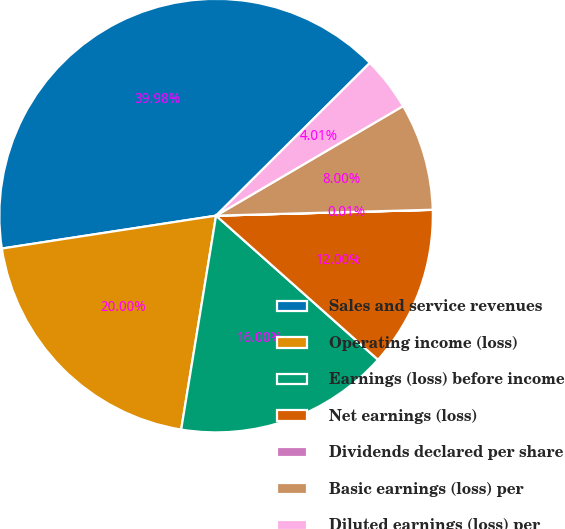<chart> <loc_0><loc_0><loc_500><loc_500><pie_chart><fcel>Sales and service revenues<fcel>Operating income (loss)<fcel>Earnings (loss) before income<fcel>Net earnings (loss)<fcel>Dividends declared per share<fcel>Basic earnings (loss) per<fcel>Diluted earnings (loss) per<nl><fcel>39.98%<fcel>20.0%<fcel>16.0%<fcel>12.0%<fcel>0.01%<fcel>8.0%<fcel>4.01%<nl></chart> 